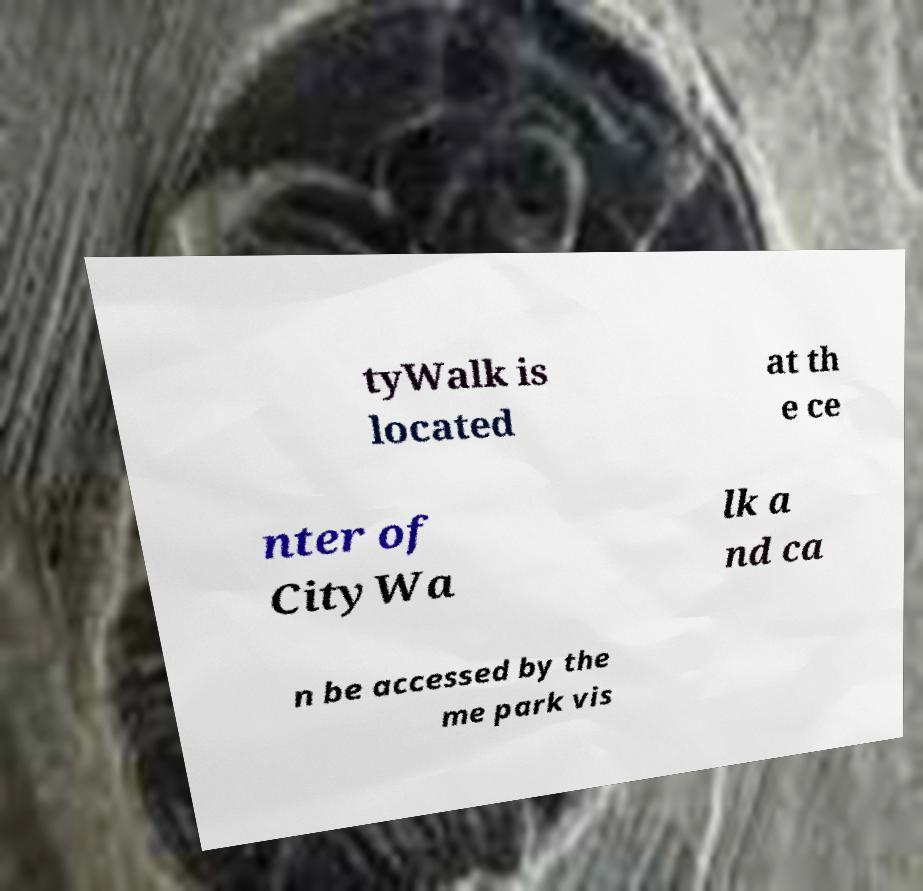I need the written content from this picture converted into text. Can you do that? tyWalk is located at th e ce nter of CityWa lk a nd ca n be accessed by the me park vis 